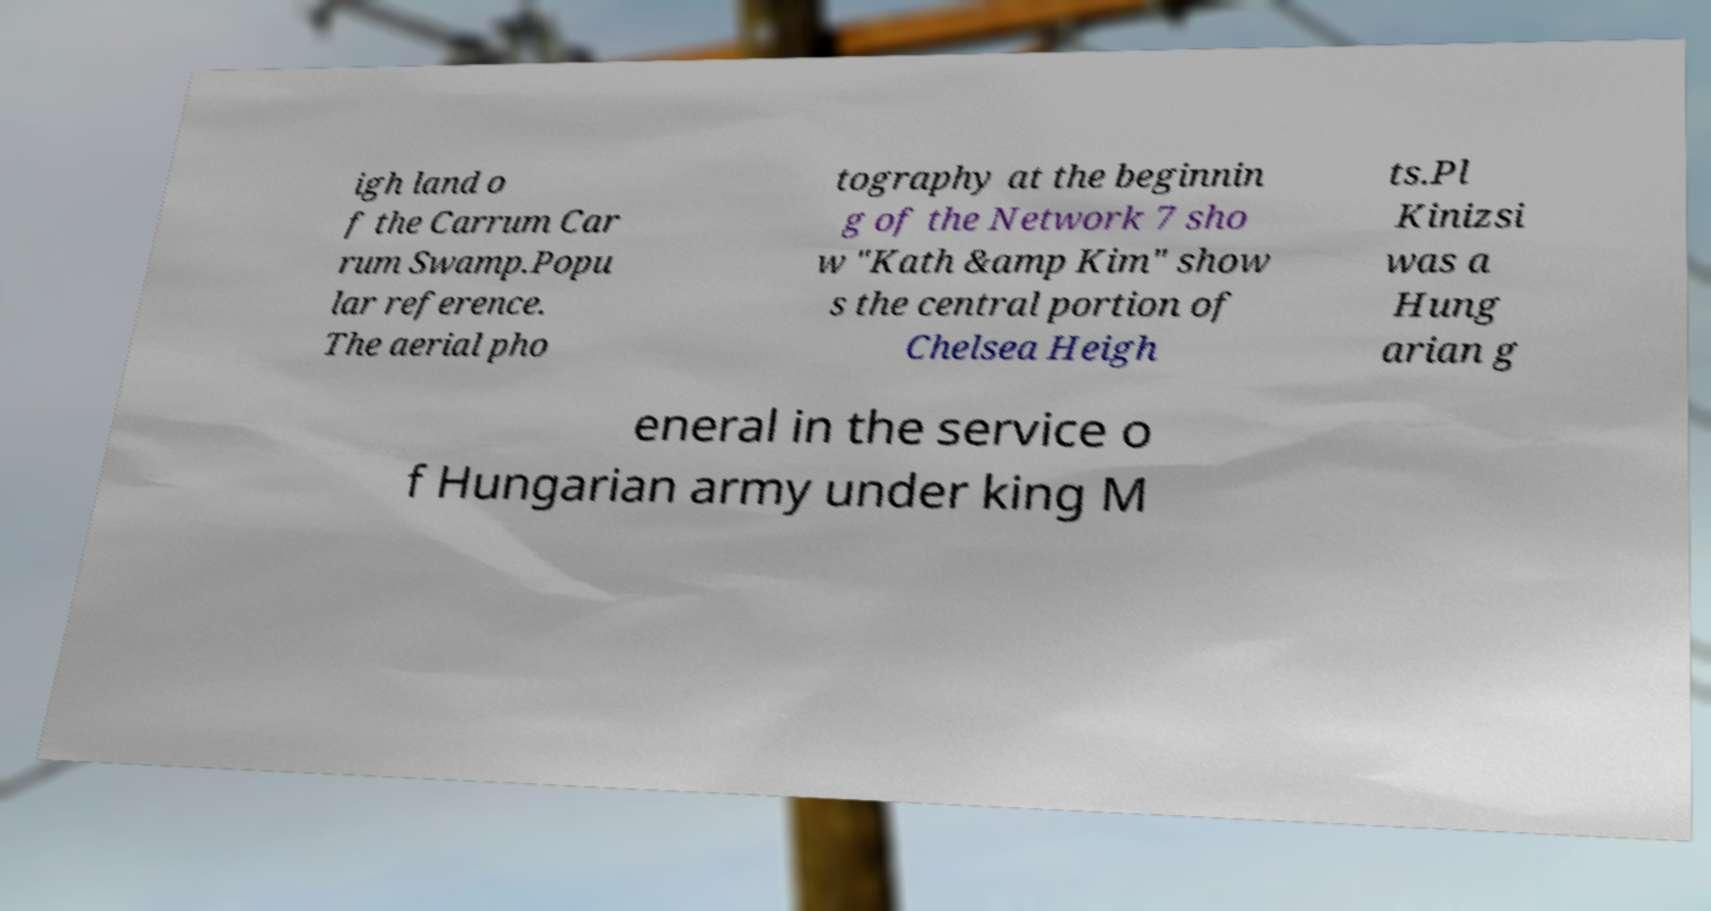Can you read and provide the text displayed in the image?This photo seems to have some interesting text. Can you extract and type it out for me? igh land o f the Carrum Car rum Swamp.Popu lar reference. The aerial pho tography at the beginnin g of the Network 7 sho w "Kath &amp Kim" show s the central portion of Chelsea Heigh ts.Pl Kinizsi was a Hung arian g eneral in the service o f Hungarian army under king M 